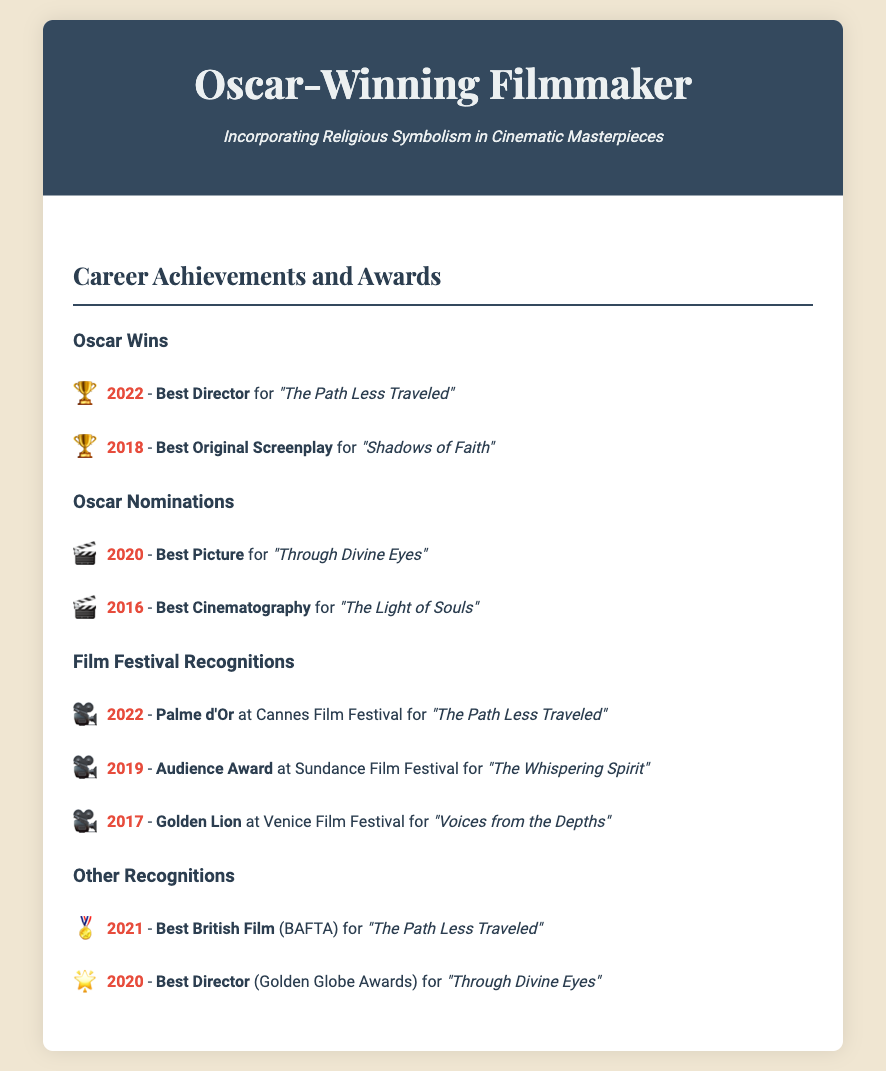What award did you win in 2022? The document lists the 2022 Oscar win for Best Director for the film "The Path Less Traveled."
Answer: Best Director How many Oscar wins are shown? The document provides two Oscar wins highlighted under the "Oscar Wins" section.
Answer: 2 Which film received the Palme d'Or? The 2022 Palme d'Or at Cannes Film Festival was awarded for "The Path Less Traveled."
Answer: "The Path Less Traveled" What year was "Shadows of Faith" awarded? This film won Best Original Screenplay in 2018, as noted under Oscar Wins.
Answer: 2018 Which award did you receive at the Venice Film Festival? The document mentions the Golden Lion awarded for "Voices from the Depths" in 2017.
Answer: Golden Lion Which film received an Audience Award at Sundance Film Festival? "The Whispering Spirit" is listed as the winner of the Audience Award in 2019.
Answer: "The Whispering Spirit" What is the subtitle in the header of the document? The subtitle mentions the filmmaker's style of incorporating religious symbolism in cinematic masterpieces.
Answer: Incorporating Religious Symbolism in Cinematic Masterpieces Which award did you receive at the BAFTA in 2021? The document states that the Best British Film award was received for "The Path Less Traveled."
Answer: Best British Film What is the year of the Golden Globe nomination? The Golden Globe nomination for Best Director is mentioned for 2020.
Answer: 2020 